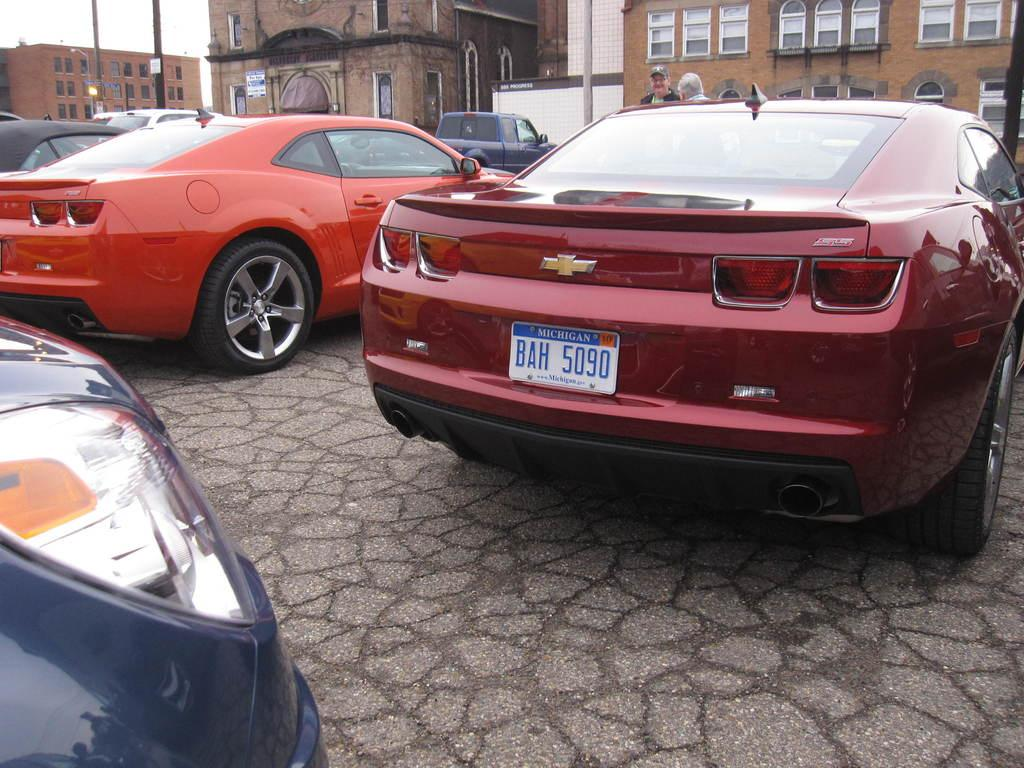What can be seen on the road in the image? There are cars on the road in the image. What is located in the background of the image? There is a pole, buildings, people, and another car in the background of the image. What part of the natural environment is visible in the image? The sky is visible in the background of the image. What type of sweater is the car wearing in the image? There is no sweater present in the image, as cars do not wear clothing. What does the land smell like in the image? There is no information about the smell of the land in the image, as smells cannot be observed visually. 